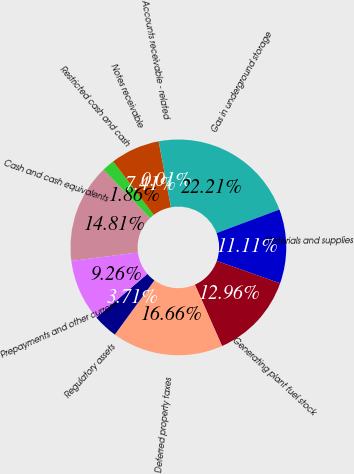Convert chart. <chart><loc_0><loc_0><loc_500><loc_500><pie_chart><fcel>Cash and cash equivalents<fcel>Restricted cash and cash<fcel>Notes receivable<fcel>Accounts receivable - related<fcel>Gas in underground storage<fcel>Materials and supplies<fcel>Generating plant fuel stock<fcel>Deferred property taxes<fcel>Regulatory assets<fcel>Prepayments and other current<nl><fcel>14.81%<fcel>1.86%<fcel>7.41%<fcel>0.01%<fcel>22.21%<fcel>11.11%<fcel>12.96%<fcel>16.66%<fcel>3.71%<fcel>9.26%<nl></chart> 